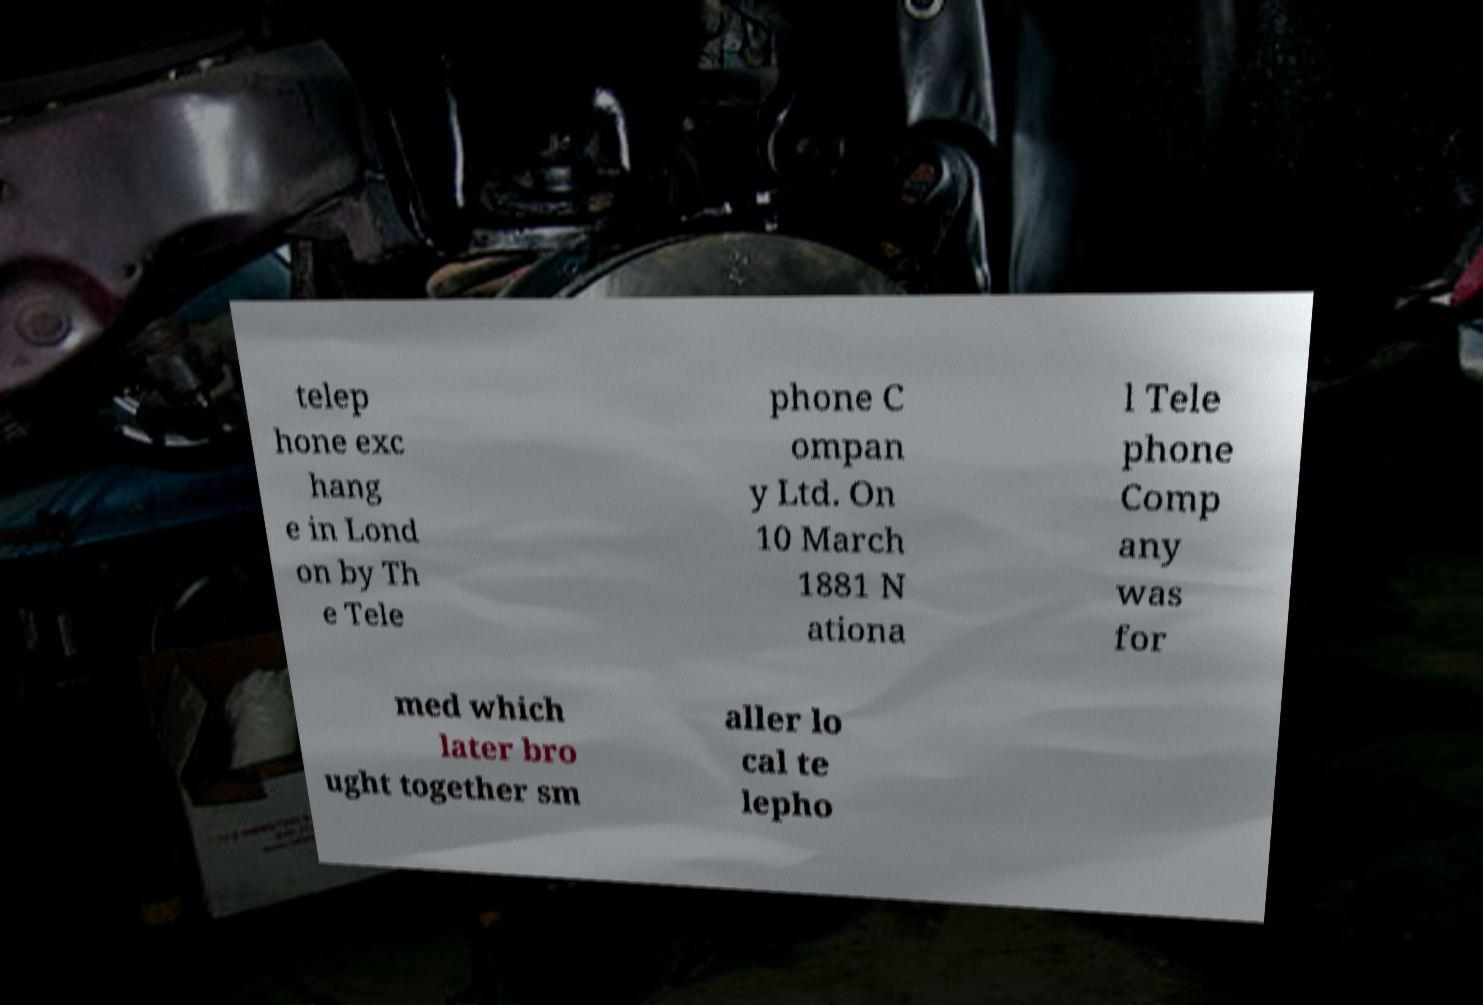There's text embedded in this image that I need extracted. Can you transcribe it verbatim? telep hone exc hang e in Lond on by Th e Tele phone C ompan y Ltd. On 10 March 1881 N ationa l Tele phone Comp any was for med which later bro ught together sm aller lo cal te lepho 